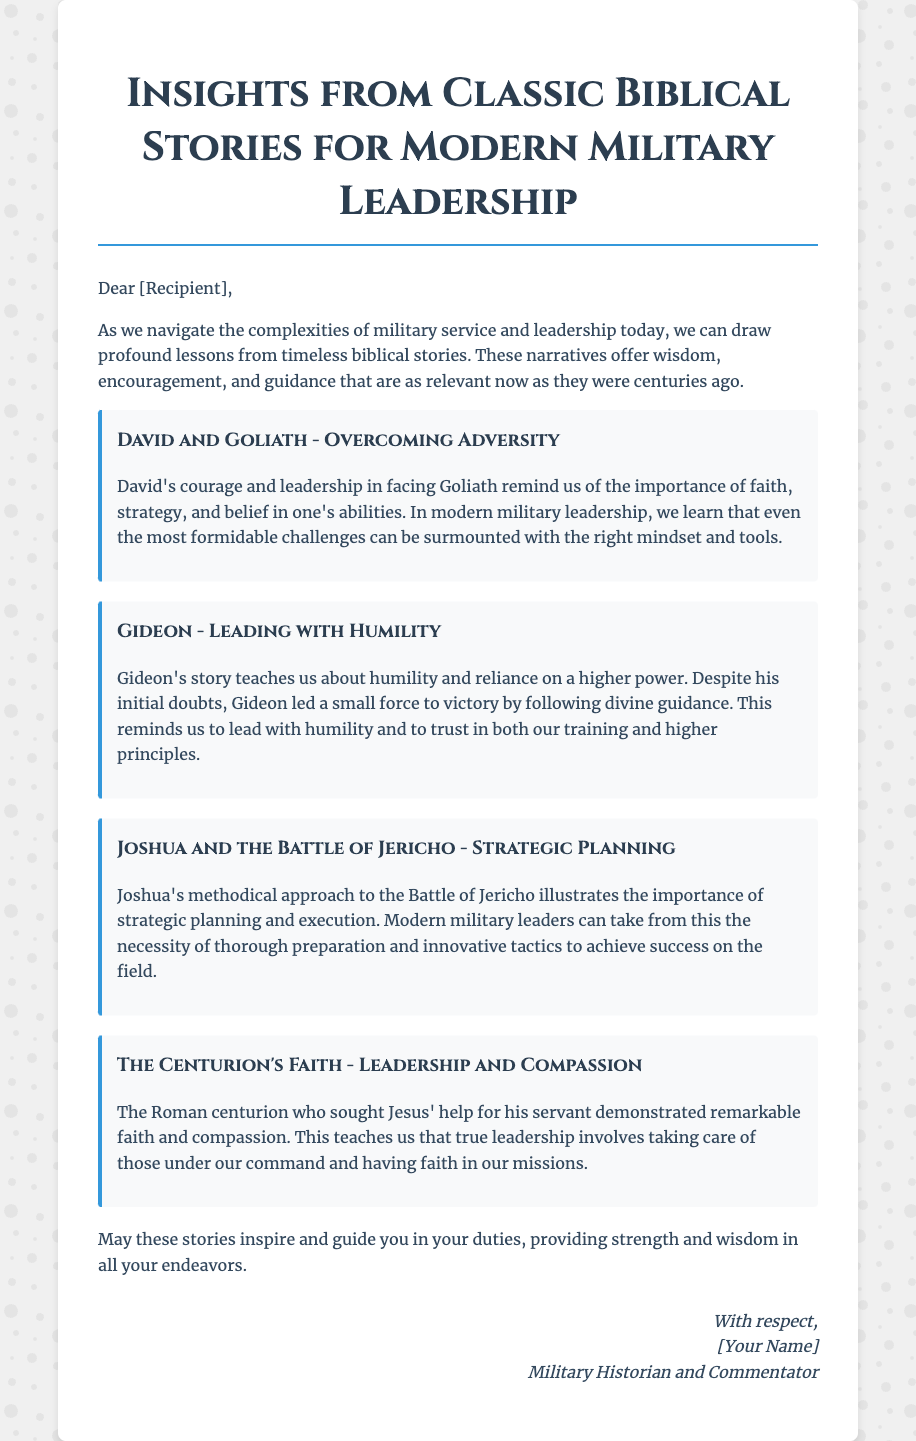What is the title of the card? The title is prominently displayed at the top of the document and reads "Insights from Classic Biblical Stories for Modern Military Leadership."
Answer: Insights from Classic Biblical Stories for Modern Military Leadership Who is the intended recipient of the message? The greeting card addresses the recipient as "[Recipient]," indicating it is a personalized message likely tailored to someone specific.
Answer: [Recipient] How many biblical stories are mentioned in the card? The document lists four specific biblical stories, each followed by a brief interpretation or lesson.
Answer: Four What does David's story teach about challenges? The story of David and Goliath emphasizes the importance of faith, strategy, and belief in overcoming adversity.
Answer: Overcoming Adversity What characteristic does Gideon's story highlight for leaders? Gideon's story serves as a lesson in humility, highlighting the importance of trusting in higher principles and guidance.
Answer: Humility What strategic approach is illustrated in Joshua's story? Joshua's methodical actions during the Battle of Jericho emphasize the importance of strategic planning and execution in military success.
Answer: Strategic Planning What quality does the Roman centurion's story reflect? The narrative of the centurion reflects remarkable faith and compassion, demonstrating essential leadership qualities.
Answer: Leadership and Compassion Who signed the card? The card is signed off by "[Your Name]," indicating it is personalized but leaves the specific name blank.
Answer: [Your Name] What tone does the message convey overall? The tone of the message is supportive and inspirational, aiming to provide strength and wisdom to the recipient.
Answer: Supportive and Inspirational 